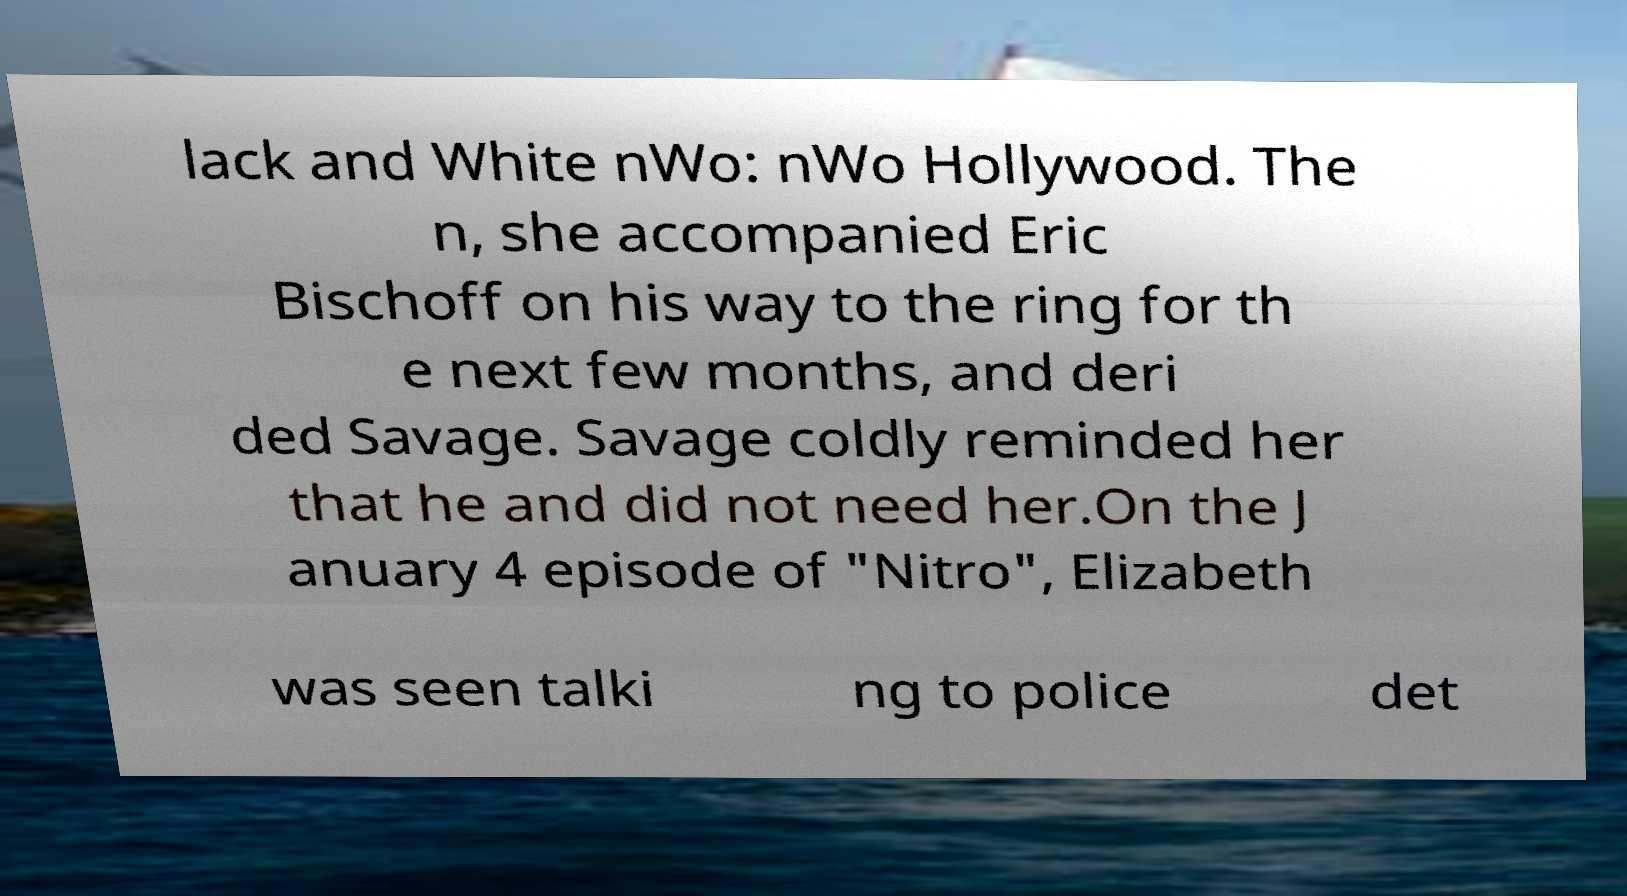What messages or text are displayed in this image? I need them in a readable, typed format. lack and White nWo: nWo Hollywood. The n, she accompanied Eric Bischoff on his way to the ring for th e next few months, and deri ded Savage. Savage coldly reminded her that he and did not need her.On the J anuary 4 episode of "Nitro", Elizabeth was seen talki ng to police det 